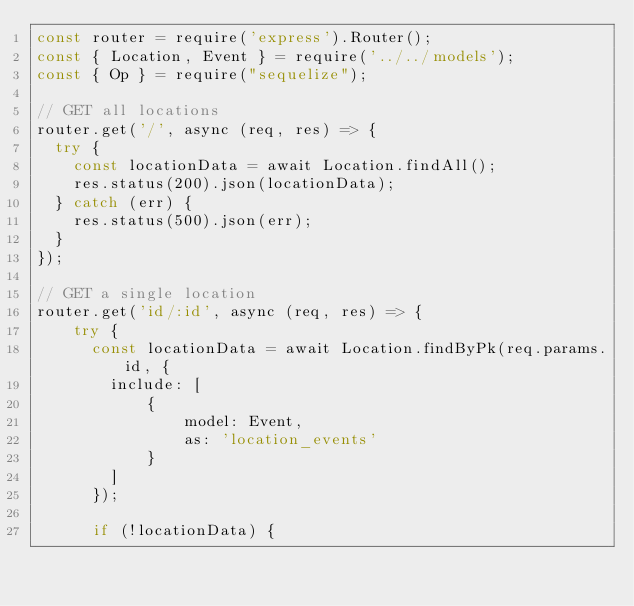<code> <loc_0><loc_0><loc_500><loc_500><_JavaScript_>const router = require('express').Router();
const { Location, Event } = require('../../models');
const { Op } = require("sequelize");

// GET all locations
router.get('/', async (req, res) => {
  try {
    const locationData = await Location.findAll();
    res.status(200).json(locationData);
  } catch (err) {
    res.status(500).json(err);
  }
});

// GET a single location
router.get('id/:id', async (req, res) => {
    try {
      const locationData = await Location.findByPk(req.params.id, {
        include: [
            { 
                model: Event, 
                as: 'location_events' 
            }
        ]
      });
  
      if (!locationData) {</code> 